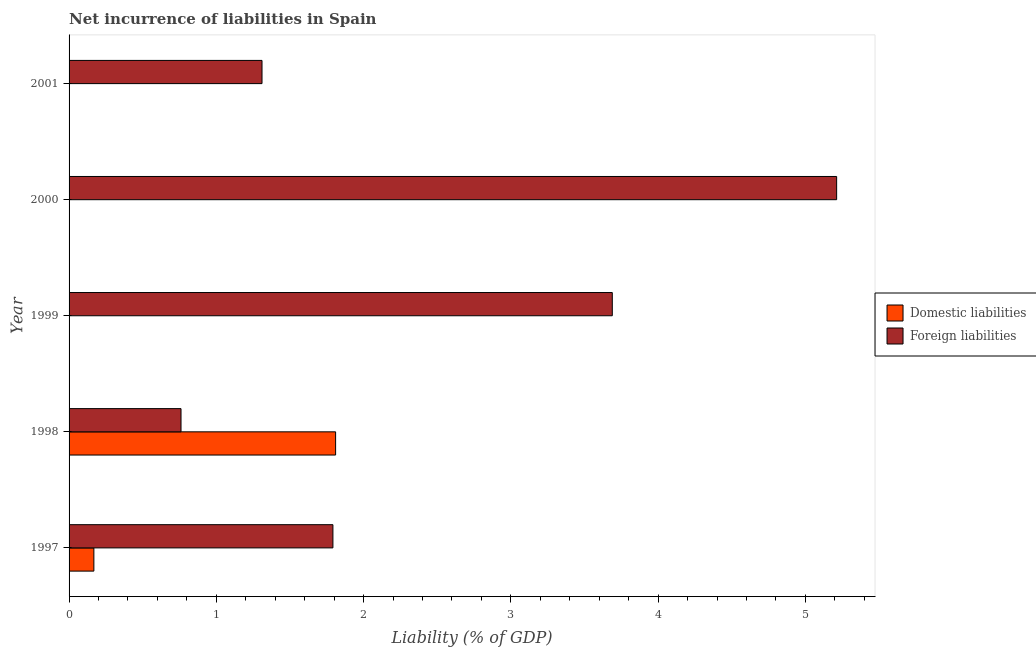How many different coloured bars are there?
Your answer should be compact. 2. Are the number of bars on each tick of the Y-axis equal?
Make the answer very short. No. What is the incurrence of foreign liabilities in 1997?
Offer a very short reply. 1.79. Across all years, what is the maximum incurrence of domestic liabilities?
Your answer should be compact. 1.81. What is the total incurrence of foreign liabilities in the graph?
Keep it short and to the point. 12.76. What is the difference between the incurrence of foreign liabilities in 1997 and that in 2000?
Offer a very short reply. -3.42. What is the difference between the incurrence of foreign liabilities in 1997 and the incurrence of domestic liabilities in 1998?
Provide a short and direct response. -0.02. What is the average incurrence of foreign liabilities per year?
Provide a succinct answer. 2.55. In how many years, is the incurrence of foreign liabilities greater than 1.8 %?
Your answer should be very brief. 2. What is the ratio of the incurrence of foreign liabilities in 1999 to that in 2001?
Ensure brevity in your answer.  2.82. What is the difference between the highest and the second highest incurrence of foreign liabilities?
Make the answer very short. 1.52. What is the difference between the highest and the lowest incurrence of domestic liabilities?
Offer a very short reply. 1.81. In how many years, is the incurrence of domestic liabilities greater than the average incurrence of domestic liabilities taken over all years?
Offer a terse response. 1. Is the sum of the incurrence of foreign liabilities in 1997 and 2001 greater than the maximum incurrence of domestic liabilities across all years?
Make the answer very short. Yes. Are all the bars in the graph horizontal?
Ensure brevity in your answer.  Yes. What is the difference between two consecutive major ticks on the X-axis?
Make the answer very short. 1. Are the values on the major ticks of X-axis written in scientific E-notation?
Provide a succinct answer. No. Does the graph contain grids?
Offer a very short reply. No. How are the legend labels stacked?
Give a very brief answer. Vertical. What is the title of the graph?
Keep it short and to the point. Net incurrence of liabilities in Spain. Does "Sanitation services" appear as one of the legend labels in the graph?
Keep it short and to the point. No. What is the label or title of the X-axis?
Keep it short and to the point. Liability (% of GDP). What is the label or title of the Y-axis?
Give a very brief answer. Year. What is the Liability (% of GDP) in Domestic liabilities in 1997?
Keep it short and to the point. 0.17. What is the Liability (% of GDP) in Foreign liabilities in 1997?
Offer a terse response. 1.79. What is the Liability (% of GDP) in Domestic liabilities in 1998?
Offer a very short reply. 1.81. What is the Liability (% of GDP) in Foreign liabilities in 1998?
Offer a very short reply. 0.76. What is the Liability (% of GDP) in Foreign liabilities in 1999?
Keep it short and to the point. 3.69. What is the Liability (% of GDP) of Foreign liabilities in 2000?
Provide a succinct answer. 5.21. What is the Liability (% of GDP) of Foreign liabilities in 2001?
Provide a succinct answer. 1.31. Across all years, what is the maximum Liability (% of GDP) in Domestic liabilities?
Provide a succinct answer. 1.81. Across all years, what is the maximum Liability (% of GDP) in Foreign liabilities?
Provide a short and direct response. 5.21. Across all years, what is the minimum Liability (% of GDP) in Foreign liabilities?
Offer a very short reply. 0.76. What is the total Liability (% of GDP) of Domestic liabilities in the graph?
Your answer should be compact. 1.98. What is the total Liability (% of GDP) of Foreign liabilities in the graph?
Provide a short and direct response. 12.76. What is the difference between the Liability (% of GDP) in Domestic liabilities in 1997 and that in 1998?
Your response must be concise. -1.64. What is the difference between the Liability (% of GDP) of Foreign liabilities in 1997 and that in 1998?
Offer a terse response. 1.03. What is the difference between the Liability (% of GDP) in Foreign liabilities in 1997 and that in 1999?
Offer a terse response. -1.9. What is the difference between the Liability (% of GDP) in Foreign liabilities in 1997 and that in 2000?
Offer a very short reply. -3.42. What is the difference between the Liability (% of GDP) in Foreign liabilities in 1997 and that in 2001?
Your response must be concise. 0.48. What is the difference between the Liability (% of GDP) in Foreign liabilities in 1998 and that in 1999?
Give a very brief answer. -2.93. What is the difference between the Liability (% of GDP) in Foreign liabilities in 1998 and that in 2000?
Make the answer very short. -4.45. What is the difference between the Liability (% of GDP) of Foreign liabilities in 1998 and that in 2001?
Provide a succinct answer. -0.55. What is the difference between the Liability (% of GDP) in Foreign liabilities in 1999 and that in 2000?
Your answer should be compact. -1.52. What is the difference between the Liability (% of GDP) in Foreign liabilities in 1999 and that in 2001?
Give a very brief answer. 2.38. What is the difference between the Liability (% of GDP) of Foreign liabilities in 2000 and that in 2001?
Provide a succinct answer. 3.9. What is the difference between the Liability (% of GDP) in Domestic liabilities in 1997 and the Liability (% of GDP) in Foreign liabilities in 1998?
Your answer should be compact. -0.59. What is the difference between the Liability (% of GDP) in Domestic liabilities in 1997 and the Liability (% of GDP) in Foreign liabilities in 1999?
Provide a short and direct response. -3.52. What is the difference between the Liability (% of GDP) in Domestic liabilities in 1997 and the Liability (% of GDP) in Foreign liabilities in 2000?
Offer a very short reply. -5.04. What is the difference between the Liability (% of GDP) in Domestic liabilities in 1997 and the Liability (% of GDP) in Foreign liabilities in 2001?
Provide a succinct answer. -1.14. What is the difference between the Liability (% of GDP) in Domestic liabilities in 1998 and the Liability (% of GDP) in Foreign liabilities in 1999?
Provide a succinct answer. -1.88. What is the difference between the Liability (% of GDP) in Domestic liabilities in 1998 and the Liability (% of GDP) in Foreign liabilities in 2000?
Make the answer very short. -3.4. What is the difference between the Liability (% of GDP) of Domestic liabilities in 1998 and the Liability (% of GDP) of Foreign liabilities in 2001?
Offer a very short reply. 0.5. What is the average Liability (% of GDP) in Domestic liabilities per year?
Provide a short and direct response. 0.4. What is the average Liability (% of GDP) of Foreign liabilities per year?
Provide a succinct answer. 2.55. In the year 1997, what is the difference between the Liability (% of GDP) in Domestic liabilities and Liability (% of GDP) in Foreign liabilities?
Ensure brevity in your answer.  -1.62. In the year 1998, what is the difference between the Liability (% of GDP) in Domestic liabilities and Liability (% of GDP) in Foreign liabilities?
Provide a short and direct response. 1.05. What is the ratio of the Liability (% of GDP) of Domestic liabilities in 1997 to that in 1998?
Provide a short and direct response. 0.09. What is the ratio of the Liability (% of GDP) in Foreign liabilities in 1997 to that in 1998?
Your response must be concise. 2.36. What is the ratio of the Liability (% of GDP) of Foreign liabilities in 1997 to that in 1999?
Make the answer very short. 0.49. What is the ratio of the Liability (% of GDP) of Foreign liabilities in 1997 to that in 2000?
Your response must be concise. 0.34. What is the ratio of the Liability (% of GDP) of Foreign liabilities in 1997 to that in 2001?
Ensure brevity in your answer.  1.37. What is the ratio of the Liability (% of GDP) in Foreign liabilities in 1998 to that in 1999?
Provide a succinct answer. 0.21. What is the ratio of the Liability (% of GDP) of Foreign liabilities in 1998 to that in 2000?
Make the answer very short. 0.15. What is the ratio of the Liability (% of GDP) of Foreign liabilities in 1998 to that in 2001?
Your answer should be very brief. 0.58. What is the ratio of the Liability (% of GDP) of Foreign liabilities in 1999 to that in 2000?
Your answer should be compact. 0.71. What is the ratio of the Liability (% of GDP) in Foreign liabilities in 1999 to that in 2001?
Ensure brevity in your answer.  2.82. What is the ratio of the Liability (% of GDP) of Foreign liabilities in 2000 to that in 2001?
Your answer should be very brief. 3.98. What is the difference between the highest and the second highest Liability (% of GDP) in Foreign liabilities?
Make the answer very short. 1.52. What is the difference between the highest and the lowest Liability (% of GDP) of Domestic liabilities?
Provide a short and direct response. 1.81. What is the difference between the highest and the lowest Liability (% of GDP) in Foreign liabilities?
Your response must be concise. 4.45. 